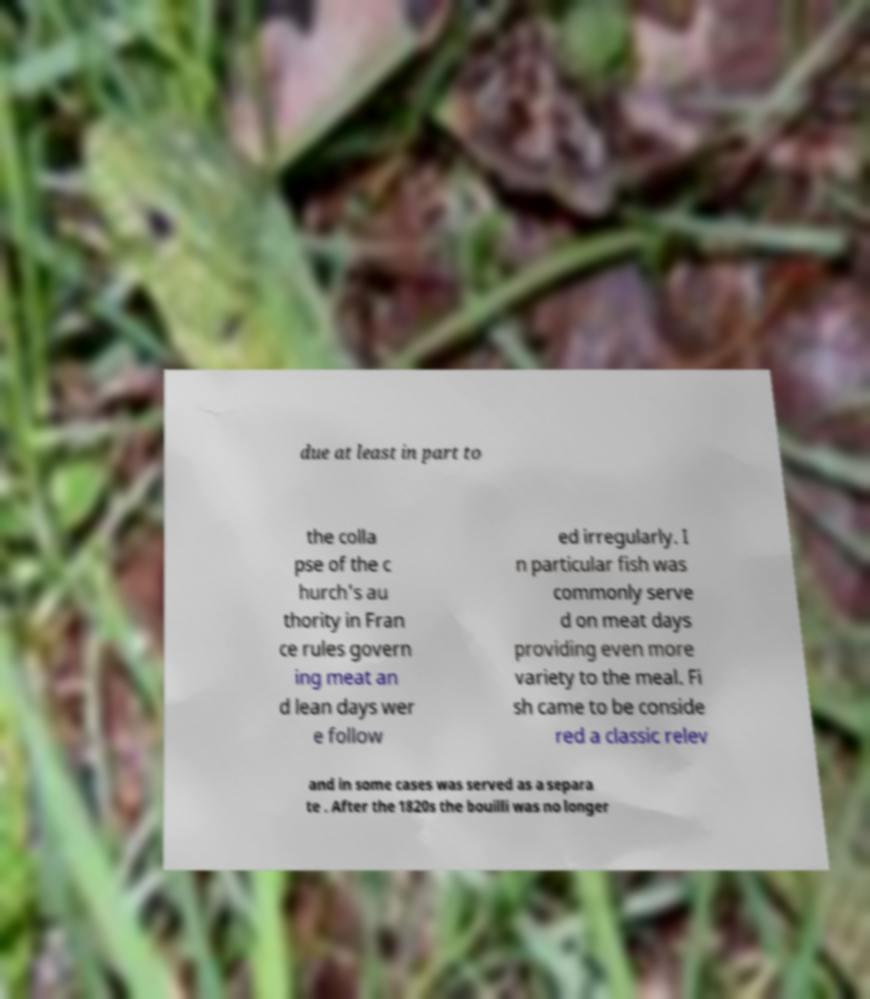Could you extract and type out the text from this image? due at least in part to the colla pse of the c hurch's au thority in Fran ce rules govern ing meat an d lean days wer e follow ed irregularly. I n particular fish was commonly serve d on meat days providing even more variety to the meal. Fi sh came to be conside red a classic relev and in some cases was served as a separa te . After the 1820s the bouilli was no longer 